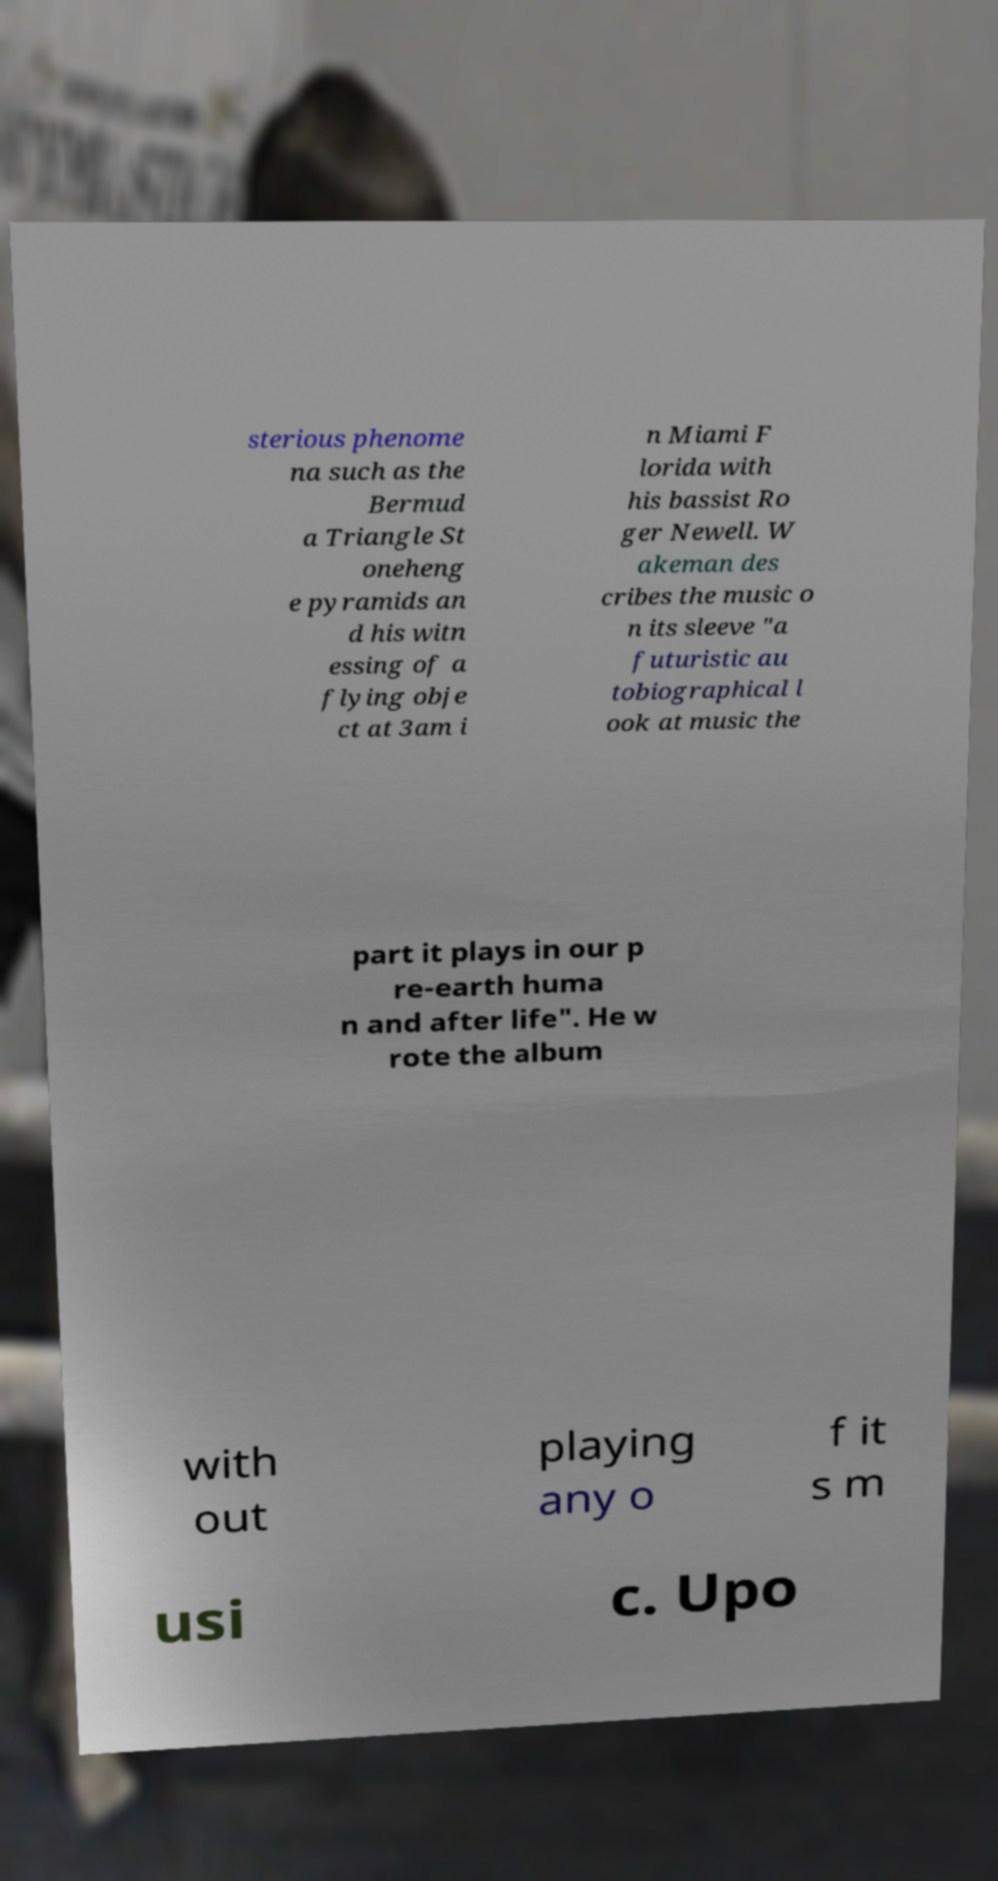Please read and relay the text visible in this image. What does it say? sterious phenome na such as the Bermud a Triangle St oneheng e pyramids an d his witn essing of a flying obje ct at 3am i n Miami F lorida with his bassist Ro ger Newell. W akeman des cribes the music o n its sleeve "a futuristic au tobiographical l ook at music the part it plays in our p re-earth huma n and after life". He w rote the album with out playing any o f it s m usi c. Upo 